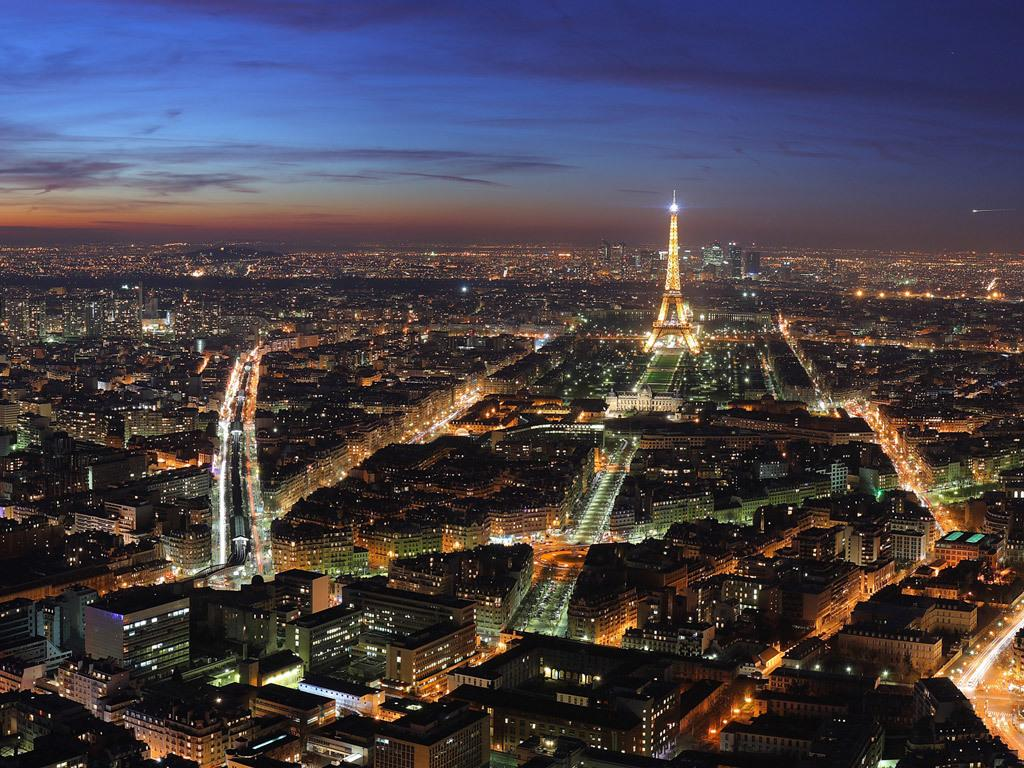What famous landmark can be seen in the image? There is an Eiffel tower in the image. What type of location is depicted in the image? The image contains a city. What can be seen in the background of the image? The sky is visible in the background of the image. What type of wood is used to construct the jeans in the image? There are no jeans present in the image, so it is not possible to determine the type of wood used in their construction. 